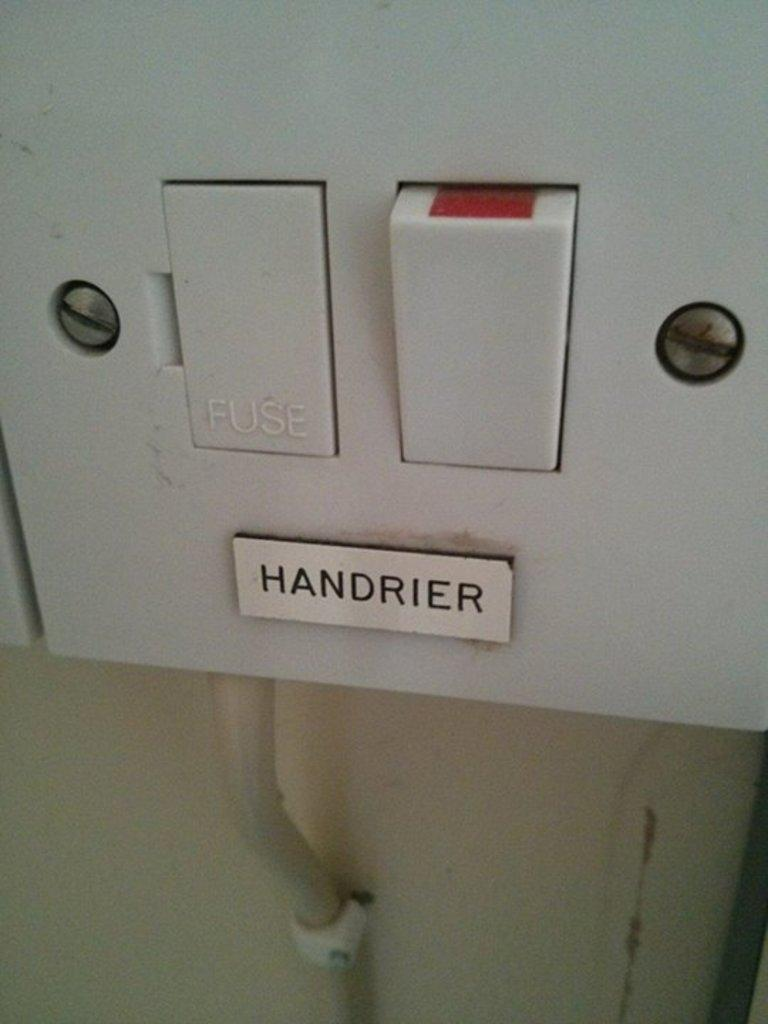What is the main object in the middle of the image? There is a switchboard in the middle of the image. Is there any identification on the switchboard? Yes, a name plate is attached to the switchboard. What can be seen at the bottom of the image? There is a cable at the bottom of the image. How is the cable connected to the wall? The cable is attached to the wall. How does the milk flow quietly in the image? There is no milk present in the image, so it cannot flow quietly or at all. 